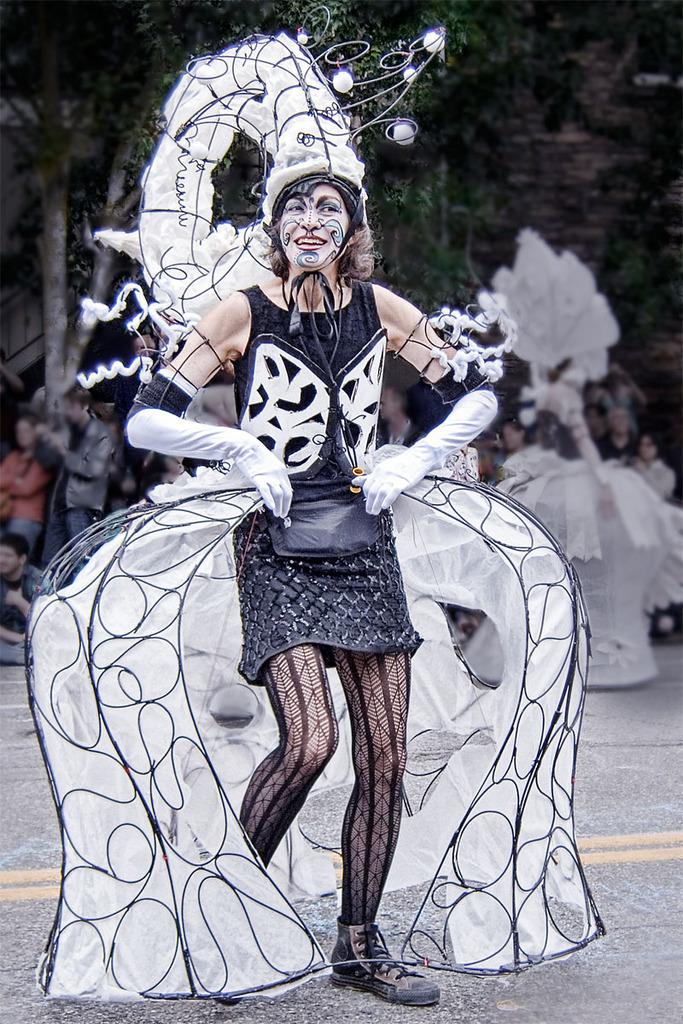What is the main subject of the image? There is a person standing on the ground in the image. Can you describe the background of the image? There is a group of people and trees visible in the background of the image. What type of glass can be seen in the person's hand in the image? There is no glass present in the person's hand or in the image. 